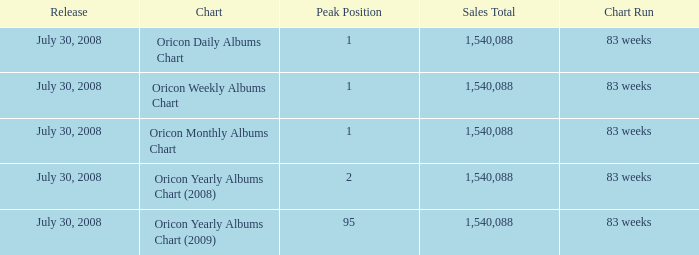Which Sales Total has a Chart of oricon monthly albums chart? 1540088.0. 